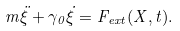<formula> <loc_0><loc_0><loc_500><loc_500>m \ddot { \xi } + \gamma _ { 0 } \dot { \xi } = F _ { e x t } ( X , t ) .</formula> 